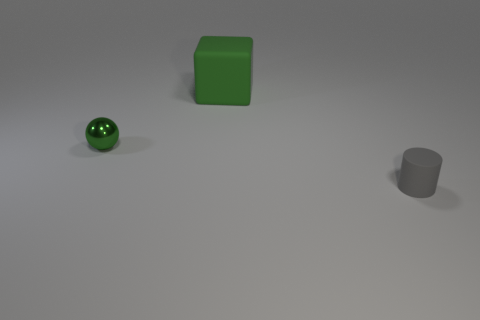Add 2 tiny red metallic blocks. How many objects exist? 5 Subtract all cylinders. How many objects are left? 2 Add 2 small gray matte cylinders. How many small gray matte cylinders are left? 3 Add 1 big brown rubber cylinders. How many big brown rubber cylinders exist? 1 Subtract 0 green cylinders. How many objects are left? 3 Subtract all large metallic spheres. Subtract all cylinders. How many objects are left? 2 